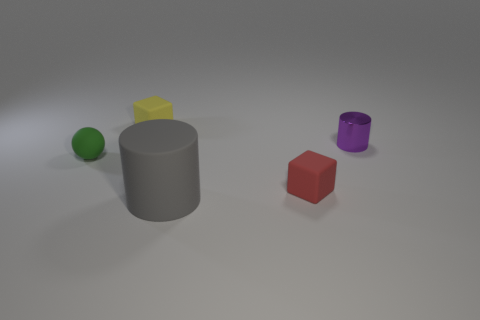Add 1 tiny green shiny balls. How many objects exist? 6 Subtract all cylinders. How many objects are left? 3 Subtract all small cyan matte objects. Subtract all tiny red things. How many objects are left? 4 Add 4 green rubber balls. How many green rubber balls are left? 5 Add 1 large rubber things. How many large rubber things exist? 2 Subtract 1 purple cylinders. How many objects are left? 4 